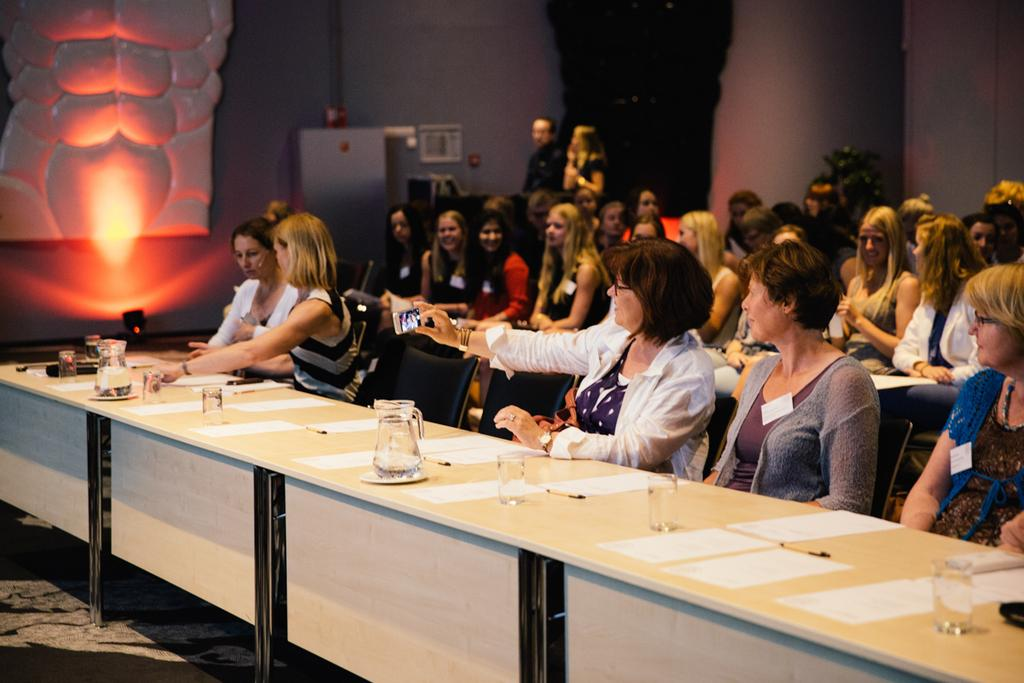What are the people in the image doing? The people in the image are sitting on chairs near a table. What objects can be seen on the table? There is a jar, a glass, papers, and a pen on the table. What type of force is being applied to the star in the image? There is no star present in the image, so no force can be applied to it. 